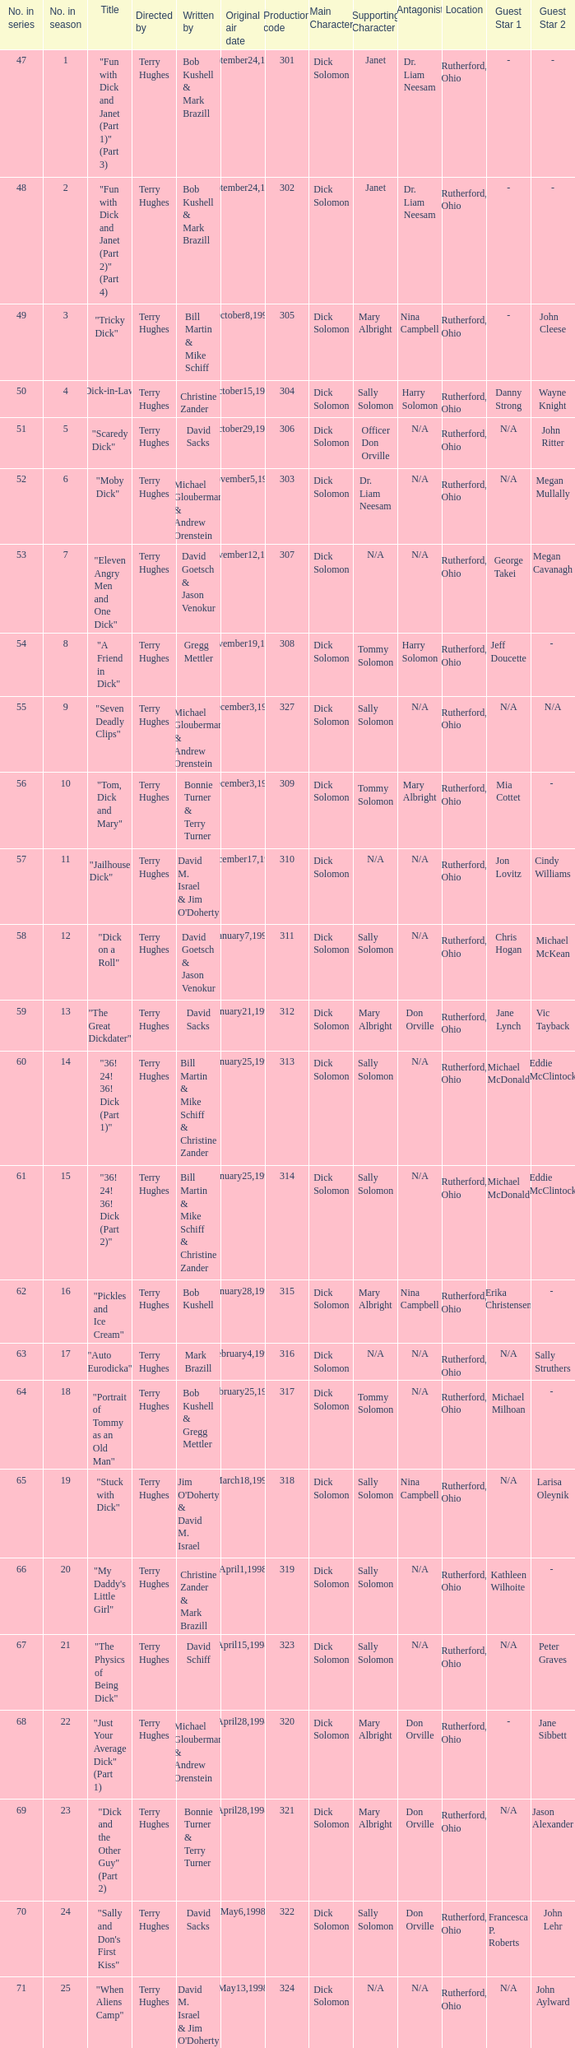Who were the writers of the episode titled "Tricky Dick"? Bill Martin & Mike Schiff. 